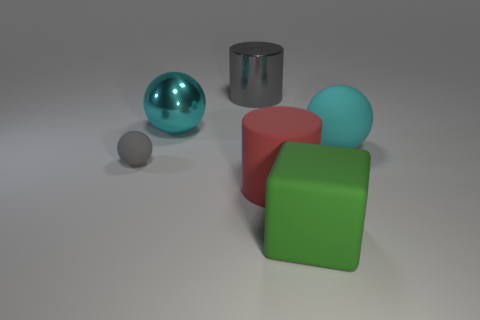Subtract all yellow balls. Subtract all green cylinders. How many balls are left? 3 Add 4 green objects. How many objects exist? 10 Subtract all cylinders. How many objects are left? 4 Add 1 matte things. How many matte things are left? 5 Add 1 tiny things. How many tiny things exist? 2 Subtract 0 gray blocks. How many objects are left? 6 Subtract all objects. Subtract all tiny purple cylinders. How many objects are left? 0 